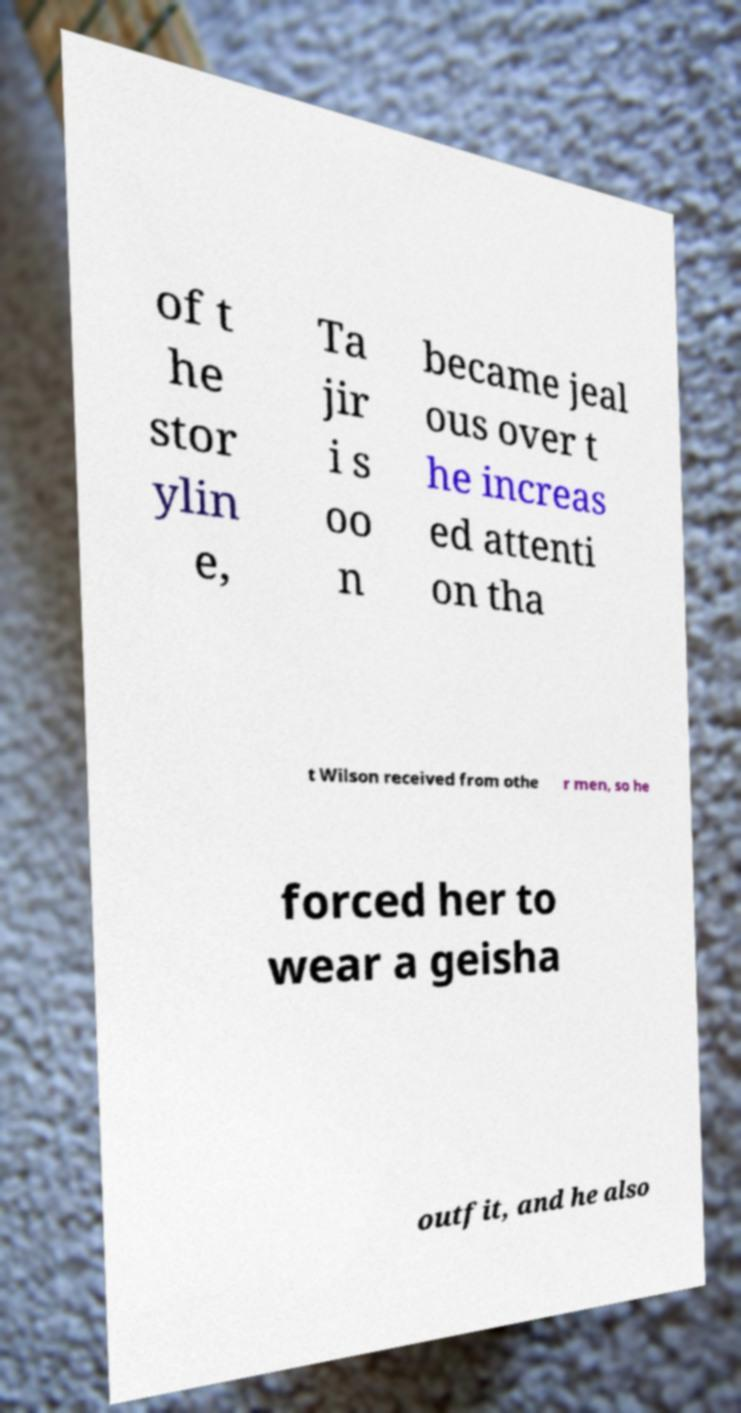What messages or text are displayed in this image? I need them in a readable, typed format. of t he stor ylin e, Ta jir i s oo n became jeal ous over t he increas ed attenti on tha t Wilson received from othe r men, so he forced her to wear a geisha outfit, and he also 